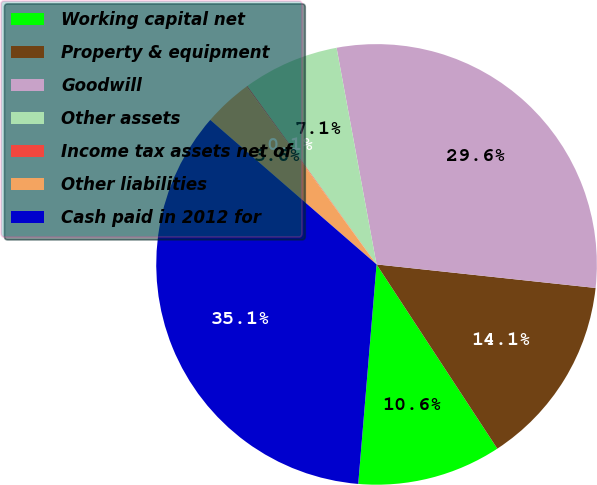<chart> <loc_0><loc_0><loc_500><loc_500><pie_chart><fcel>Working capital net<fcel>Property & equipment<fcel>Goodwill<fcel>Other assets<fcel>Income tax assets net of<fcel>Other liabilities<fcel>Cash paid in 2012 for<nl><fcel>10.56%<fcel>14.06%<fcel>29.61%<fcel>7.07%<fcel>0.07%<fcel>3.57%<fcel>35.06%<nl></chart> 